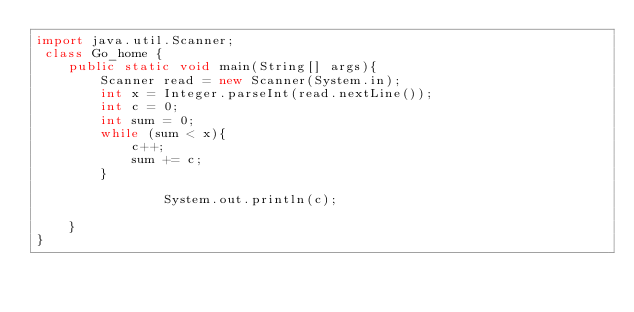Convert code to text. <code><loc_0><loc_0><loc_500><loc_500><_Java_>import java.util.Scanner;
 class Go_home {
    public static void main(String[] args){
        Scanner read = new Scanner(System.in);
        int x = Integer.parseInt(read.nextLine());
        int c = 0;
        int sum = 0;
        while (sum < x){
            c++;
            sum += c;
        }

                System.out.println(c);

    }
}</code> 